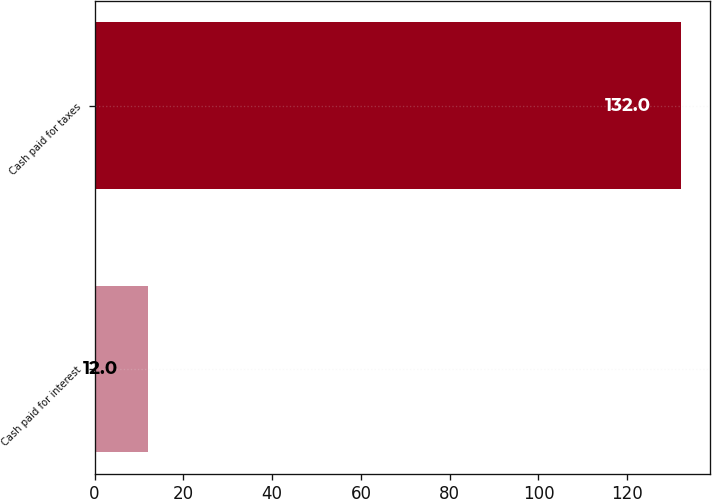Convert chart to OTSL. <chart><loc_0><loc_0><loc_500><loc_500><bar_chart><fcel>Cash paid for interest<fcel>Cash paid for taxes<nl><fcel>12<fcel>132<nl></chart> 